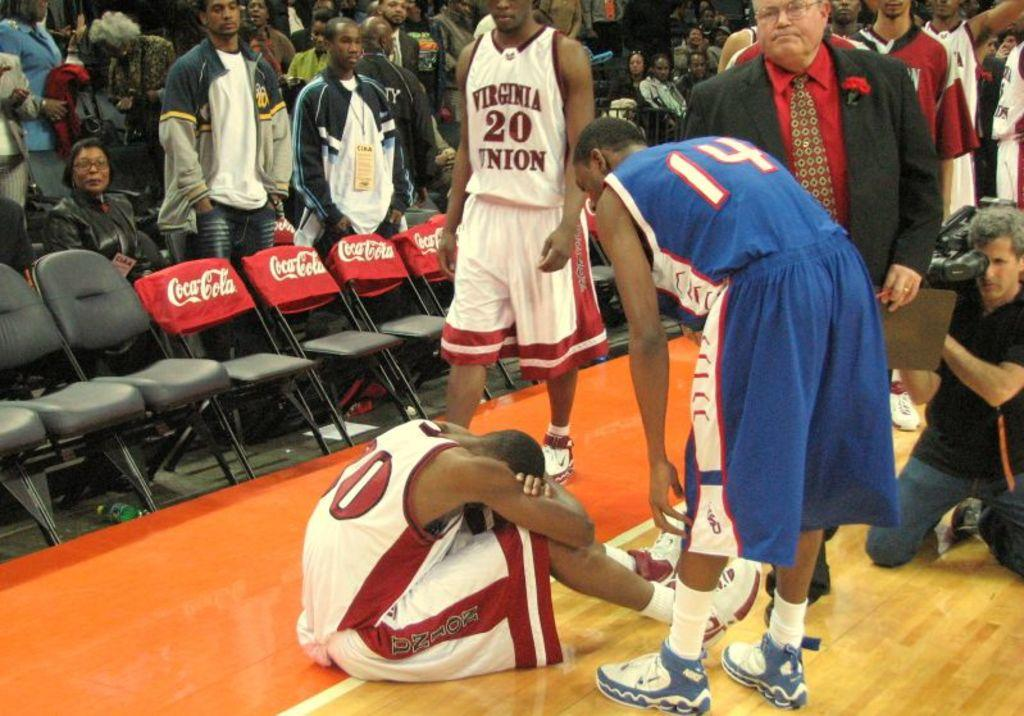Provide a one-sentence caption for the provided image. A Virginia Union player sits on the floor of the basketball court in front of ads for Coca Cola. 